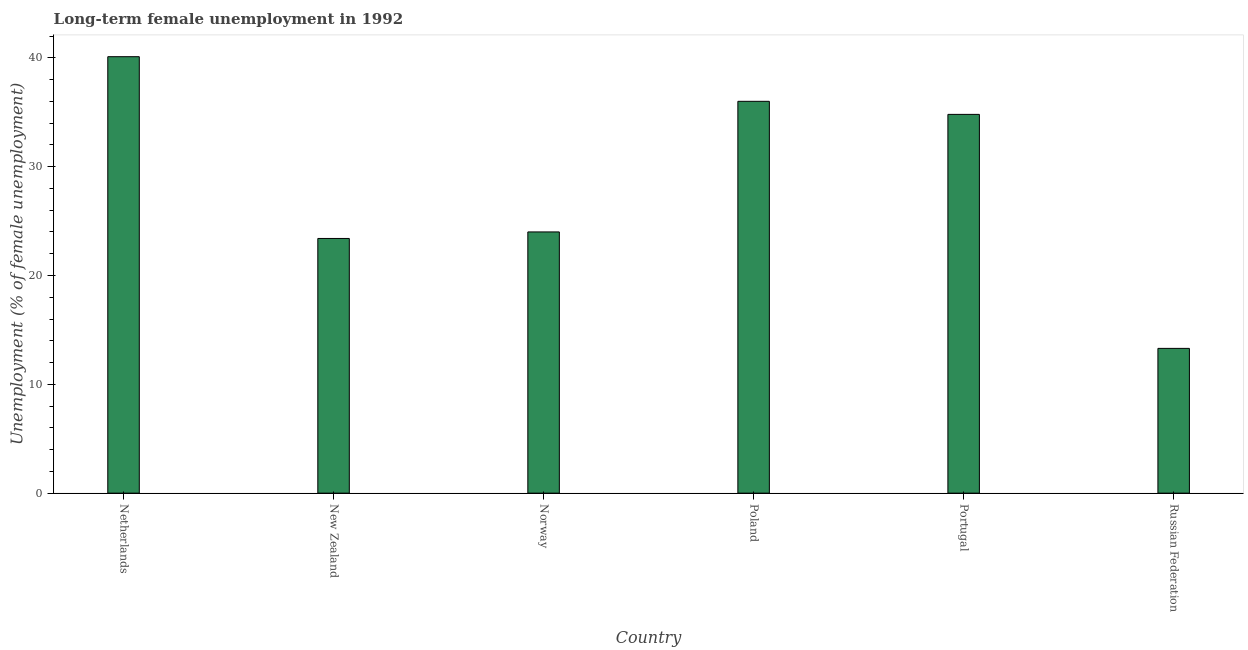What is the title of the graph?
Offer a terse response. Long-term female unemployment in 1992. What is the label or title of the Y-axis?
Your answer should be compact. Unemployment (% of female unemployment). What is the long-term female unemployment in Russian Federation?
Make the answer very short. 13.3. Across all countries, what is the maximum long-term female unemployment?
Your response must be concise. 40.1. Across all countries, what is the minimum long-term female unemployment?
Your answer should be compact. 13.3. In which country was the long-term female unemployment maximum?
Your answer should be compact. Netherlands. In which country was the long-term female unemployment minimum?
Your answer should be compact. Russian Federation. What is the sum of the long-term female unemployment?
Keep it short and to the point. 171.6. What is the difference between the long-term female unemployment in New Zealand and Poland?
Your response must be concise. -12.6. What is the average long-term female unemployment per country?
Keep it short and to the point. 28.6. What is the median long-term female unemployment?
Offer a very short reply. 29.4. What is the ratio of the long-term female unemployment in New Zealand to that in Russian Federation?
Offer a terse response. 1.76. What is the difference between the highest and the lowest long-term female unemployment?
Offer a very short reply. 26.8. In how many countries, is the long-term female unemployment greater than the average long-term female unemployment taken over all countries?
Make the answer very short. 3. How many bars are there?
Give a very brief answer. 6. How many countries are there in the graph?
Give a very brief answer. 6. Are the values on the major ticks of Y-axis written in scientific E-notation?
Provide a short and direct response. No. What is the Unemployment (% of female unemployment) of Netherlands?
Your answer should be very brief. 40.1. What is the Unemployment (% of female unemployment) of New Zealand?
Ensure brevity in your answer.  23.4. What is the Unemployment (% of female unemployment) of Norway?
Provide a succinct answer. 24. What is the Unemployment (% of female unemployment) in Poland?
Ensure brevity in your answer.  36. What is the Unemployment (% of female unemployment) of Portugal?
Offer a terse response. 34.8. What is the Unemployment (% of female unemployment) of Russian Federation?
Make the answer very short. 13.3. What is the difference between the Unemployment (% of female unemployment) in Netherlands and Portugal?
Offer a terse response. 5.3. What is the difference between the Unemployment (% of female unemployment) in Netherlands and Russian Federation?
Provide a succinct answer. 26.8. What is the difference between the Unemployment (% of female unemployment) in New Zealand and Poland?
Provide a succinct answer. -12.6. What is the difference between the Unemployment (% of female unemployment) in New Zealand and Russian Federation?
Provide a succinct answer. 10.1. What is the difference between the Unemployment (% of female unemployment) in Norway and Portugal?
Make the answer very short. -10.8. What is the difference between the Unemployment (% of female unemployment) in Norway and Russian Federation?
Keep it short and to the point. 10.7. What is the difference between the Unemployment (% of female unemployment) in Poland and Portugal?
Make the answer very short. 1.2. What is the difference between the Unemployment (% of female unemployment) in Poland and Russian Federation?
Give a very brief answer. 22.7. What is the ratio of the Unemployment (% of female unemployment) in Netherlands to that in New Zealand?
Provide a succinct answer. 1.71. What is the ratio of the Unemployment (% of female unemployment) in Netherlands to that in Norway?
Give a very brief answer. 1.67. What is the ratio of the Unemployment (% of female unemployment) in Netherlands to that in Poland?
Give a very brief answer. 1.11. What is the ratio of the Unemployment (% of female unemployment) in Netherlands to that in Portugal?
Offer a very short reply. 1.15. What is the ratio of the Unemployment (% of female unemployment) in Netherlands to that in Russian Federation?
Provide a short and direct response. 3.02. What is the ratio of the Unemployment (% of female unemployment) in New Zealand to that in Norway?
Offer a terse response. 0.97. What is the ratio of the Unemployment (% of female unemployment) in New Zealand to that in Poland?
Your answer should be very brief. 0.65. What is the ratio of the Unemployment (% of female unemployment) in New Zealand to that in Portugal?
Offer a terse response. 0.67. What is the ratio of the Unemployment (% of female unemployment) in New Zealand to that in Russian Federation?
Keep it short and to the point. 1.76. What is the ratio of the Unemployment (% of female unemployment) in Norway to that in Poland?
Your answer should be compact. 0.67. What is the ratio of the Unemployment (% of female unemployment) in Norway to that in Portugal?
Provide a succinct answer. 0.69. What is the ratio of the Unemployment (% of female unemployment) in Norway to that in Russian Federation?
Ensure brevity in your answer.  1.8. What is the ratio of the Unemployment (% of female unemployment) in Poland to that in Portugal?
Offer a terse response. 1.03. What is the ratio of the Unemployment (% of female unemployment) in Poland to that in Russian Federation?
Offer a terse response. 2.71. What is the ratio of the Unemployment (% of female unemployment) in Portugal to that in Russian Federation?
Ensure brevity in your answer.  2.62. 